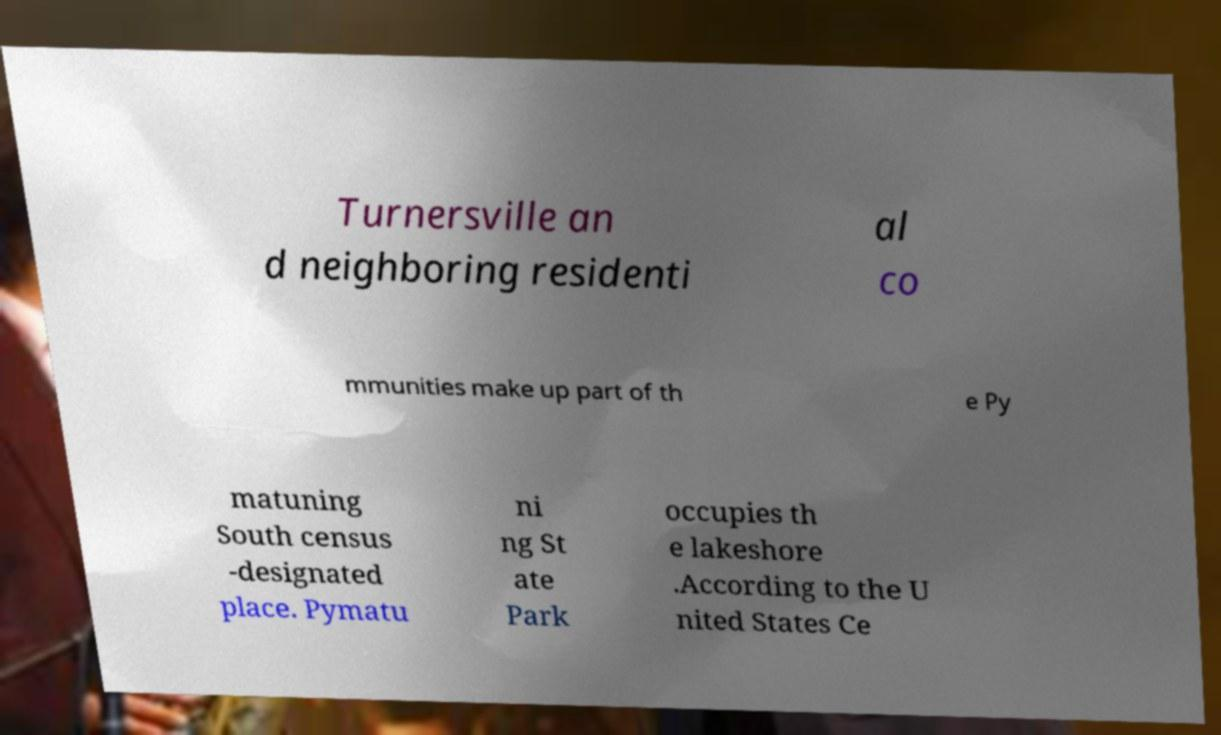Can you accurately transcribe the text from the provided image for me? Turnersville an d neighboring residenti al co mmunities make up part of th e Py matuning South census -designated place. Pymatu ni ng St ate Park occupies th e lakeshore .According to the U nited States Ce 